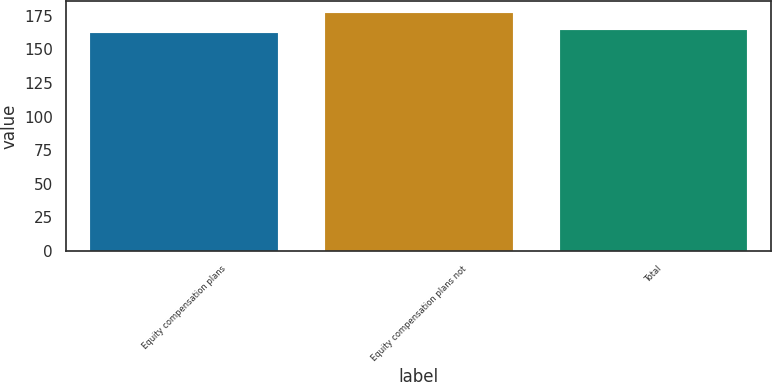Convert chart. <chart><loc_0><loc_0><loc_500><loc_500><bar_chart><fcel>Equity compensation plans<fcel>Equity compensation plans not<fcel>Total<nl><fcel>162.17<fcel>176.85<fcel>164.16<nl></chart> 